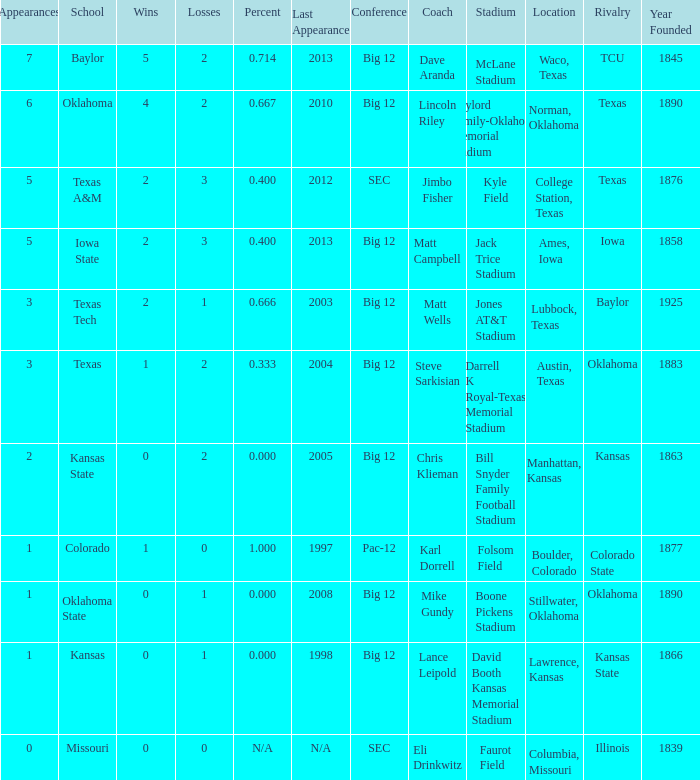How many schools had the win loss ratio of 0.667?  1.0. 